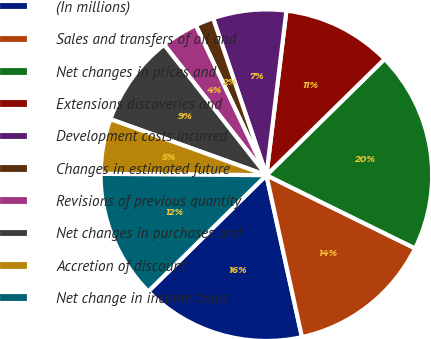Convert chart. <chart><loc_0><loc_0><loc_500><loc_500><pie_chart><fcel>(In millions)<fcel>Sales and transfers of oil and<fcel>Net changes in prices and<fcel>Extensions discoveries and<fcel>Development costs incurred<fcel>Changes in estimated future<fcel>Revisions of previous quantity<fcel>Net changes in purchases and<fcel>Accretion of discount<fcel>Net change in income taxes<nl><fcel>16.07%<fcel>14.28%<fcel>19.64%<fcel>10.71%<fcel>7.14%<fcel>1.79%<fcel>3.58%<fcel>8.93%<fcel>5.36%<fcel>12.5%<nl></chart> 